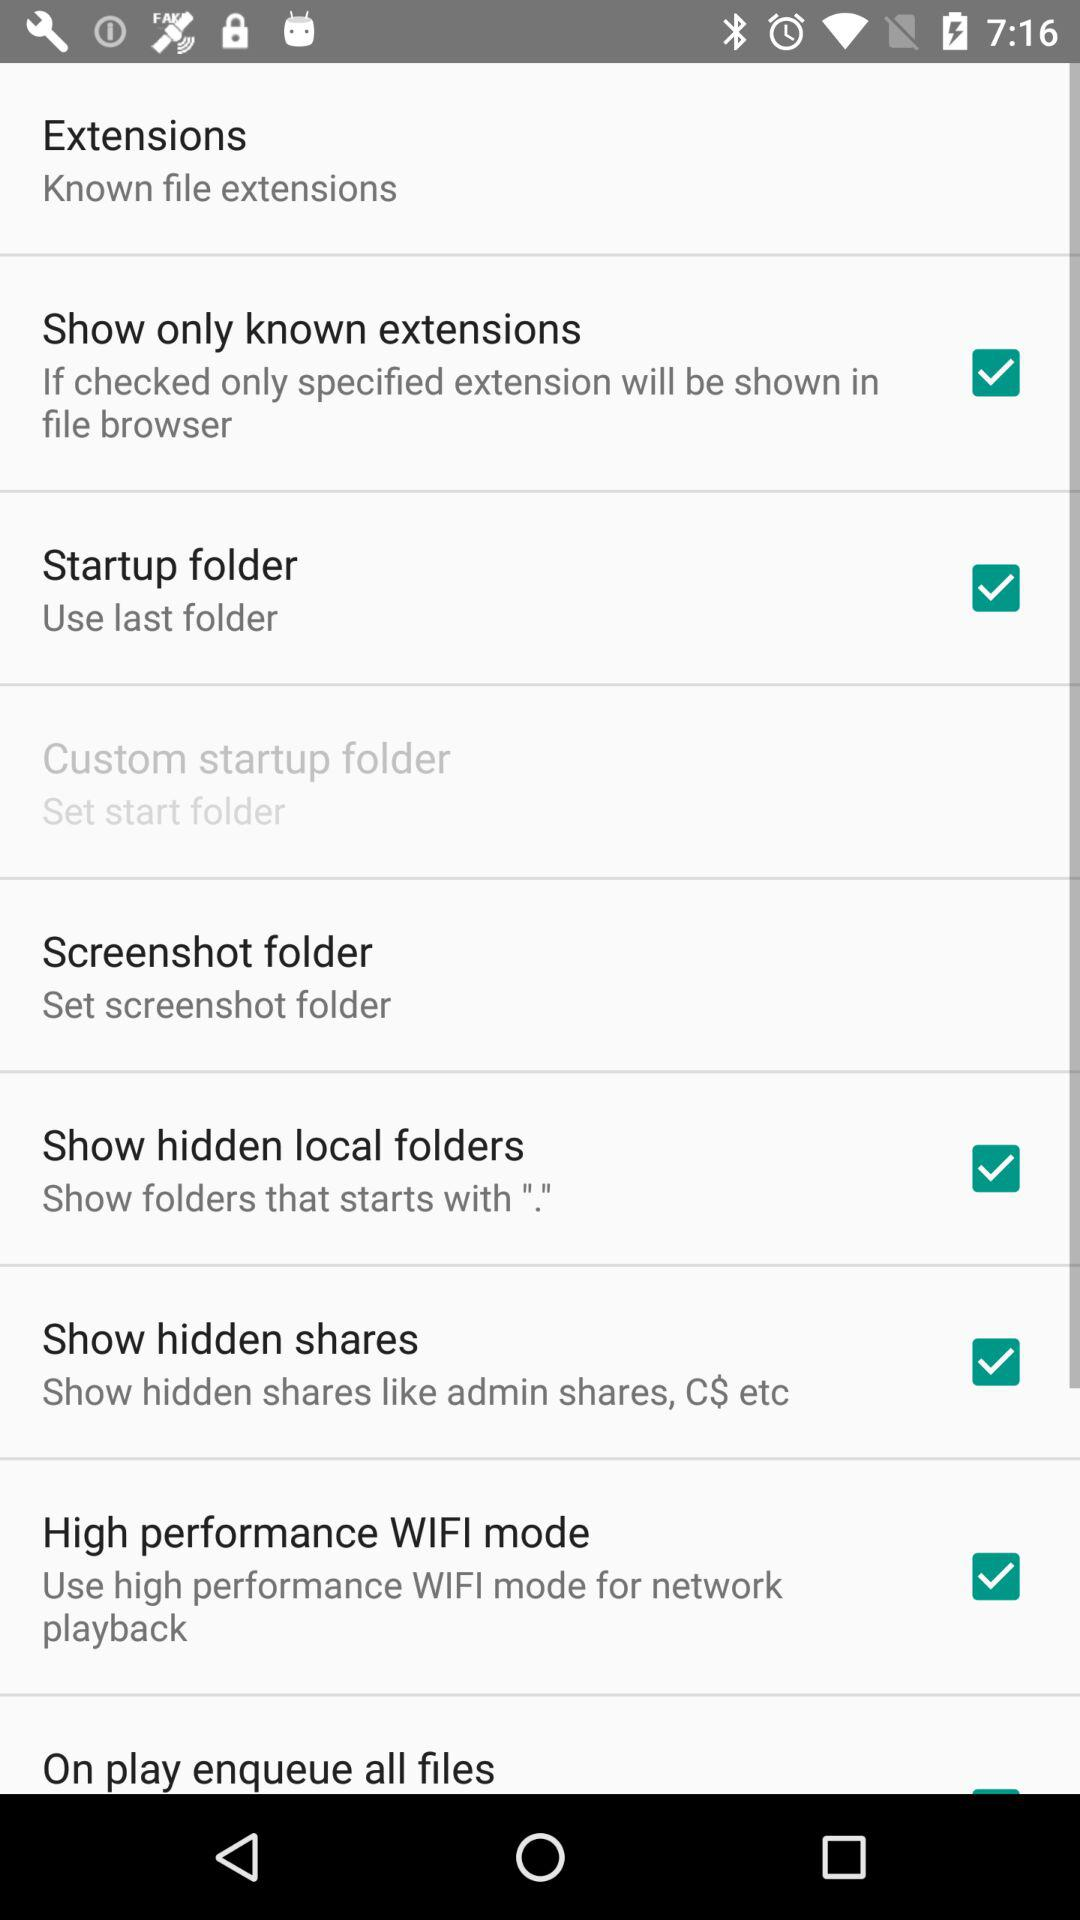What is the setting for the startup folder? The setting for the startup folder is "Use last folder". 